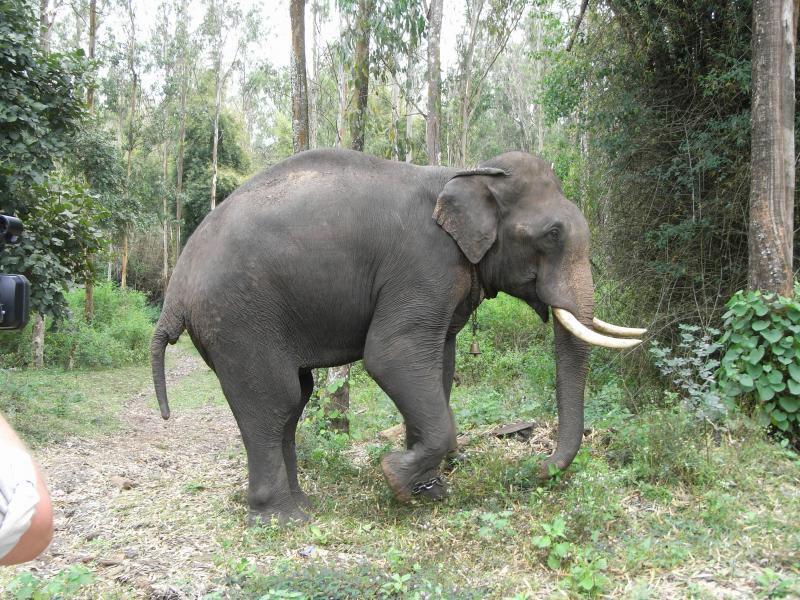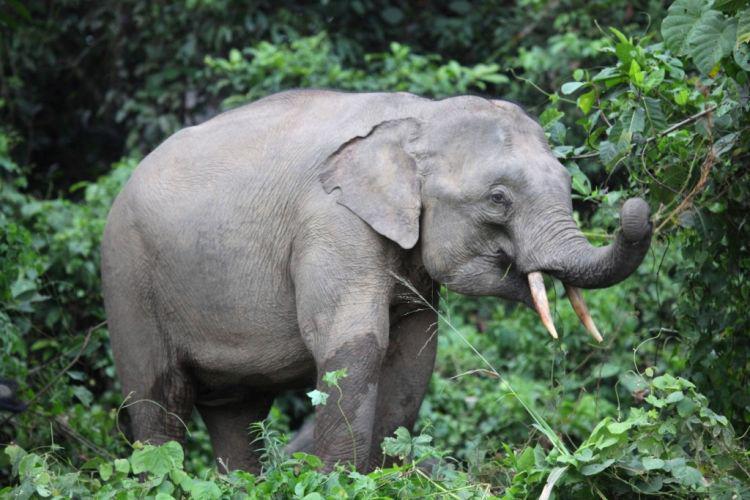The first image is the image on the left, the second image is the image on the right. For the images shown, is this caption "Only one image shows a single elephant with tusks." true? Answer yes or no. No. The first image is the image on the left, the second image is the image on the right. For the images displayed, is the sentence "There is exactly one elephant in the image on the right." factually correct? Answer yes or no. Yes. 